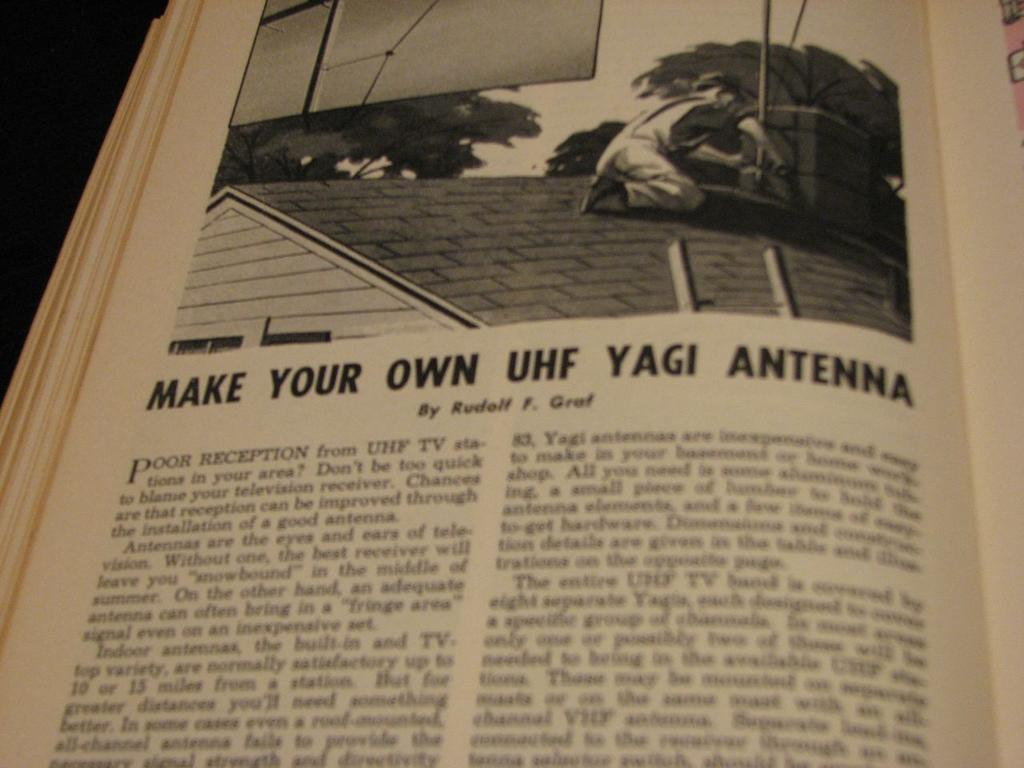<image>
Describe the image concisely. A book is open to a page about how to make your own UHF yagi antenna. 